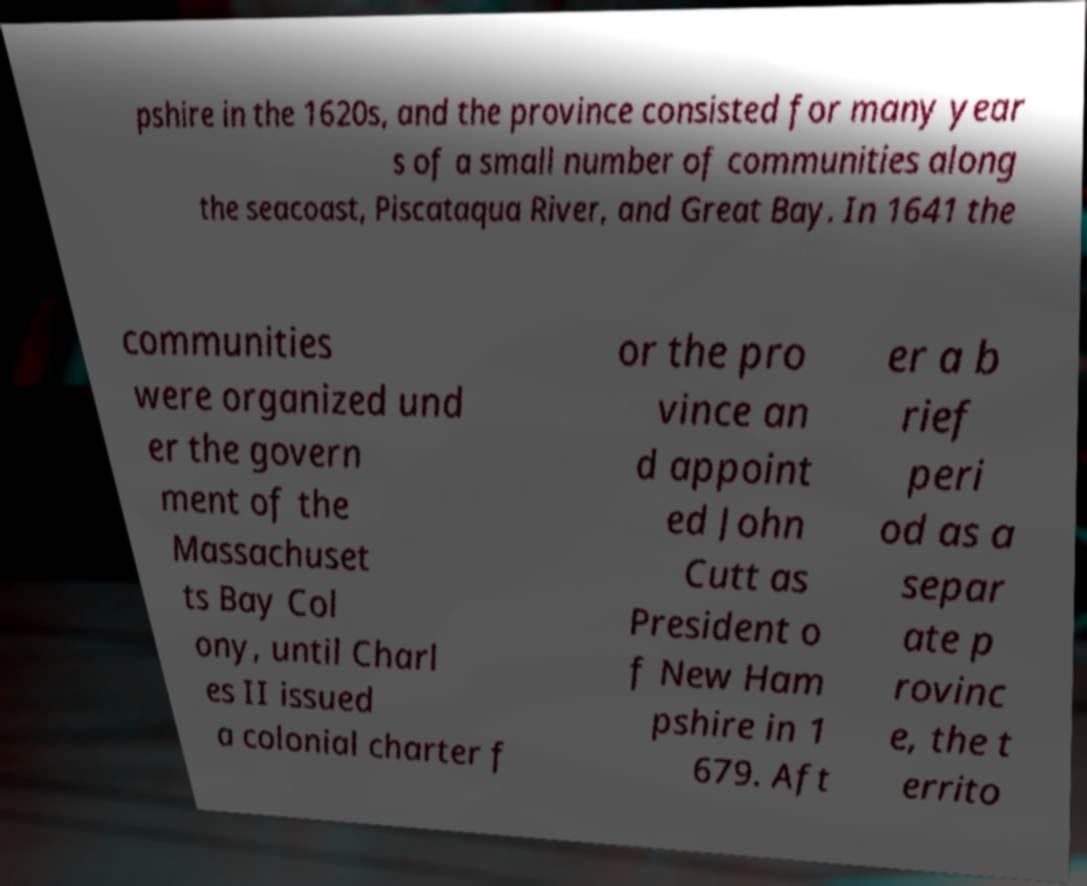Can you accurately transcribe the text from the provided image for me? pshire in the 1620s, and the province consisted for many year s of a small number of communities along the seacoast, Piscataqua River, and Great Bay. In 1641 the communities were organized und er the govern ment of the Massachuset ts Bay Col ony, until Charl es II issued a colonial charter f or the pro vince an d appoint ed John Cutt as President o f New Ham pshire in 1 679. Aft er a b rief peri od as a separ ate p rovinc e, the t errito 